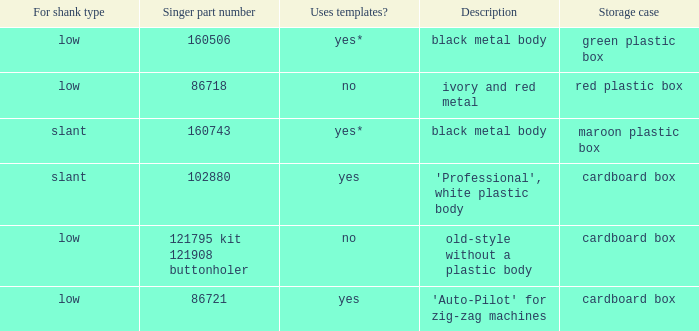What's the singer part number of the buttonholer whose storage case is a green plastic box? 160506.0. 